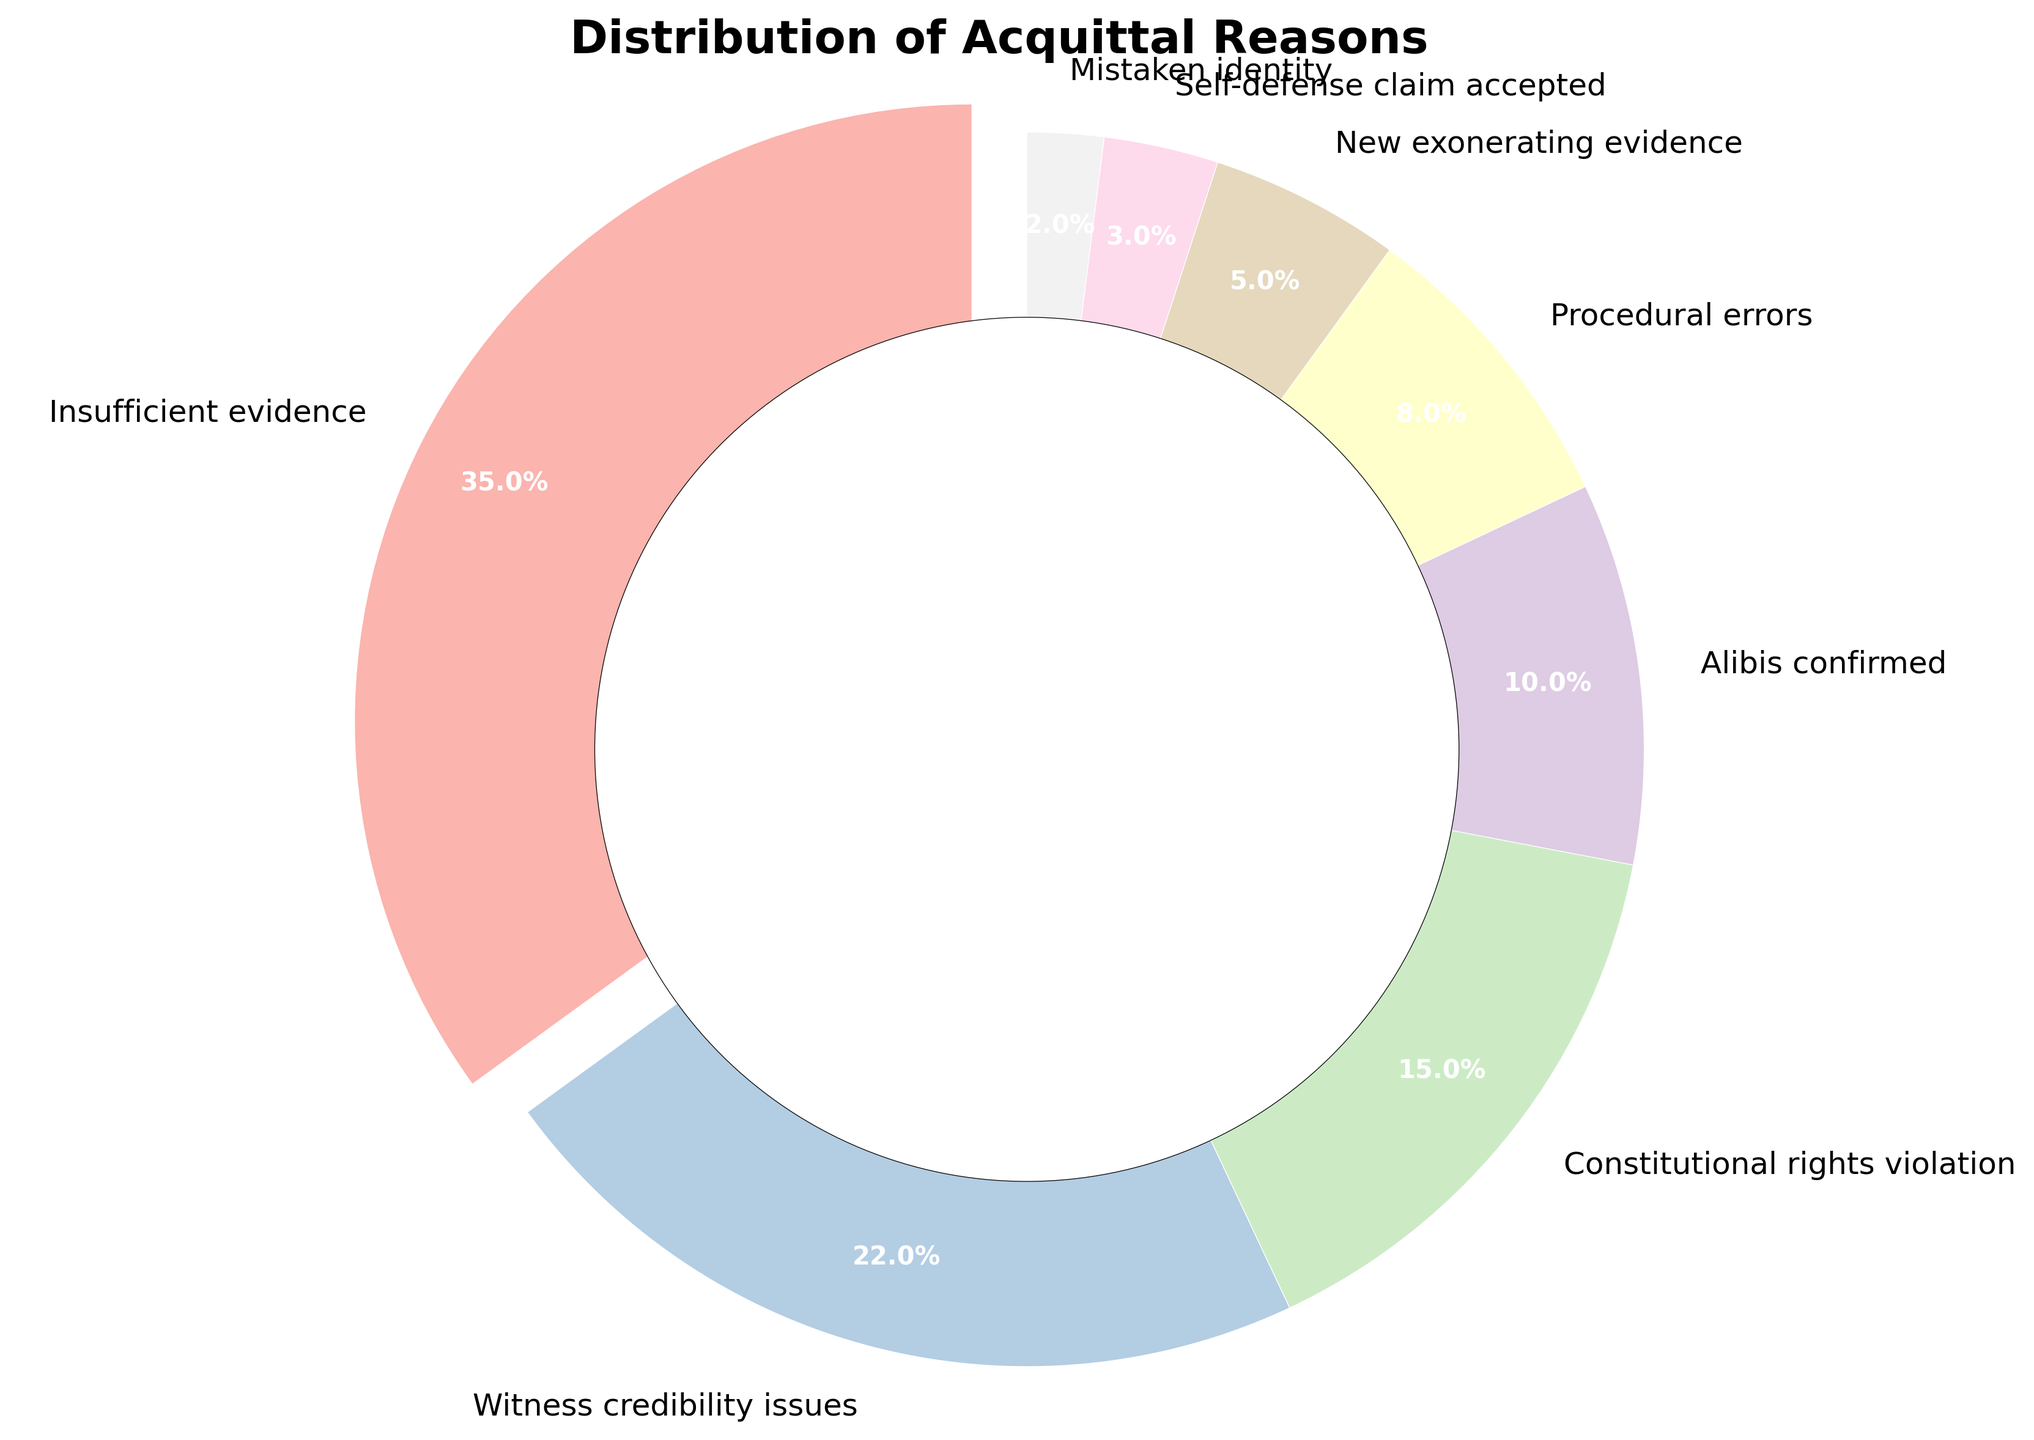What is the most common reason for acquittal? The category with the highest percentage represents the most common reason for acquittal. In the plot, the segment 'Insufficient evidence' has the largest slice and is also separated slightly from the rest for emphasis.
Answer: Insufficient evidence How much larger is the percentage of 'Insufficient evidence' compared to 'Witness credibility issues'? Find the percentage of each reason from the figure: Insufficient evidence (35%) and Witness credibility issues (22%). Then subtract the smaller percentage from the larger one: 35% - 22% = 13%.
Answer: 13% What is the total percentage for reasons related to evidence issues, which includes 'Insufficient evidence' and 'New exonerating evidence'? Sum the percentages of the reasons related to evidence issues: Insufficient evidence (35%) + New exonerating evidence (5%) = 40%.
Answer: 40% Are 'Constitutional rights violation' and 'Alibis confirmed' together more or less than 'Witness credibility issues'? Add the percentages of 'Constitutional rights violation' (15%) and 'Alibis confirmed' (10%), resulting in 15% + 10% = 25%. Compare this with 'Witness credibility issues' (22%). 25% is greater than 22%.
Answer: More Which segment has the lightest color in the plot, and what percentage does it represent? Pastel shades are used, with lighter colors typically at the high end of a gradient. The smallest and lightest segment is 'Mistaken identity', representing 2%.
Answer: Mistaken identity, 2% What is the combined percentage of the three least common reasons for acquittal? Identify the three segments with the smallest percentages: Self-defense claim accepted (3%), Mistaken identity (2%), and New exonerating evidence (5%). Add these: 3% + 2% + 5% = 10%.
Answer: 10% Does 'Procedural errors' contribute more or less than 'Alibis confirmed' to the total acquittal reasons? Compare the percentages: Procedural errors (8%) and Alibis confirmed (10%). The percentage for Procedural errors is less than that for Alibis confirmed.
Answer: Less If 'Witness credibility issues' and 'Procedural errors' were to be combined into one category, what would be their new combined percentage? Add the percentages of 'Witness credibility issues' (22%) and 'Procedural errors' (8%): 22% + 8% = 30%.
Answer: 30% How does the percentage of cases acquitted due to 'Self-defense claim accepted' compare to those due to 'New exonerating evidence'? Compare the percentages: Self-defense claim accepted (3%) and New exonerating evidence (5%). 3% is less than 5%.
Answer: Less What fraction of the total cases does 'New exonerating evidence' and 'Mistaken identity' together represent? Find the percentages of 'New exonerating evidence' (5%) and 'Mistaken identity' (2%), then add them: 5% + 2% = 7%. The fraction is 7/100, which simplifies to 7%.
Answer: 7% 